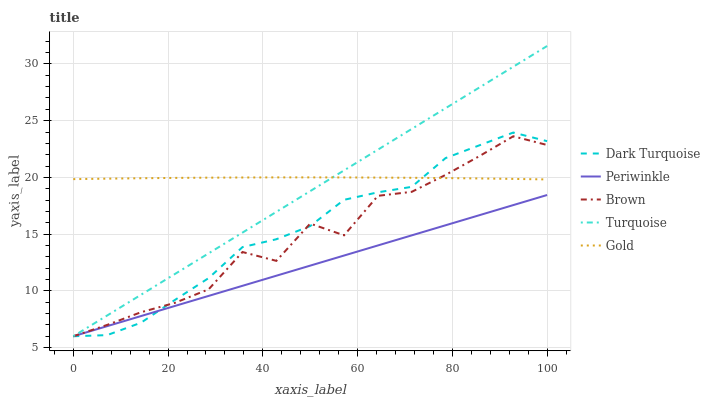Does Turquoise have the minimum area under the curve?
Answer yes or no. No. Does Turquoise have the maximum area under the curve?
Answer yes or no. No. Is Turquoise the smoothest?
Answer yes or no. No. Is Turquoise the roughest?
Answer yes or no. No. Does Gold have the lowest value?
Answer yes or no. No. Does Periwinkle have the highest value?
Answer yes or no. No. Is Periwinkle less than Gold?
Answer yes or no. Yes. Is Gold greater than Periwinkle?
Answer yes or no. Yes. Does Periwinkle intersect Gold?
Answer yes or no. No. 